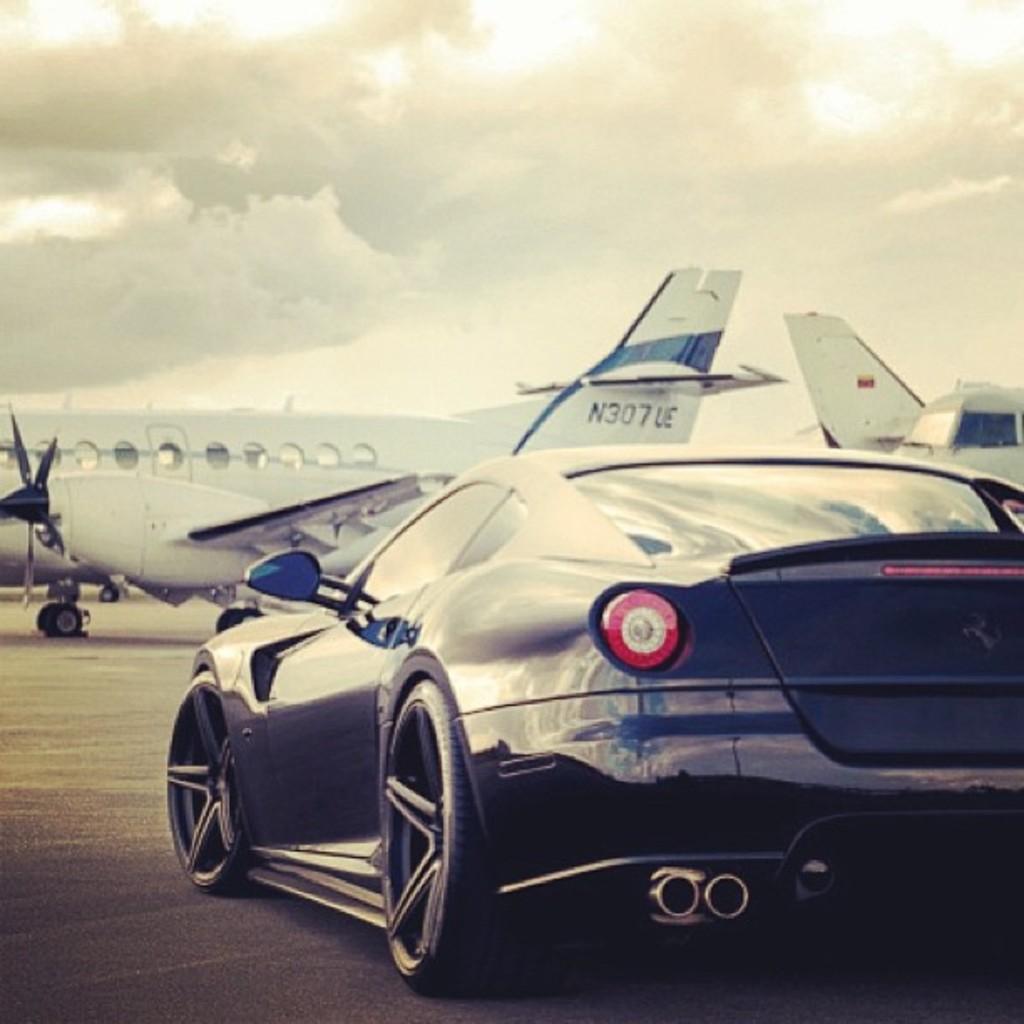What is the number on the plane?
Keep it short and to the point. N307ue. What is the number on the plane fin?
Your answer should be compact. N307ue. 